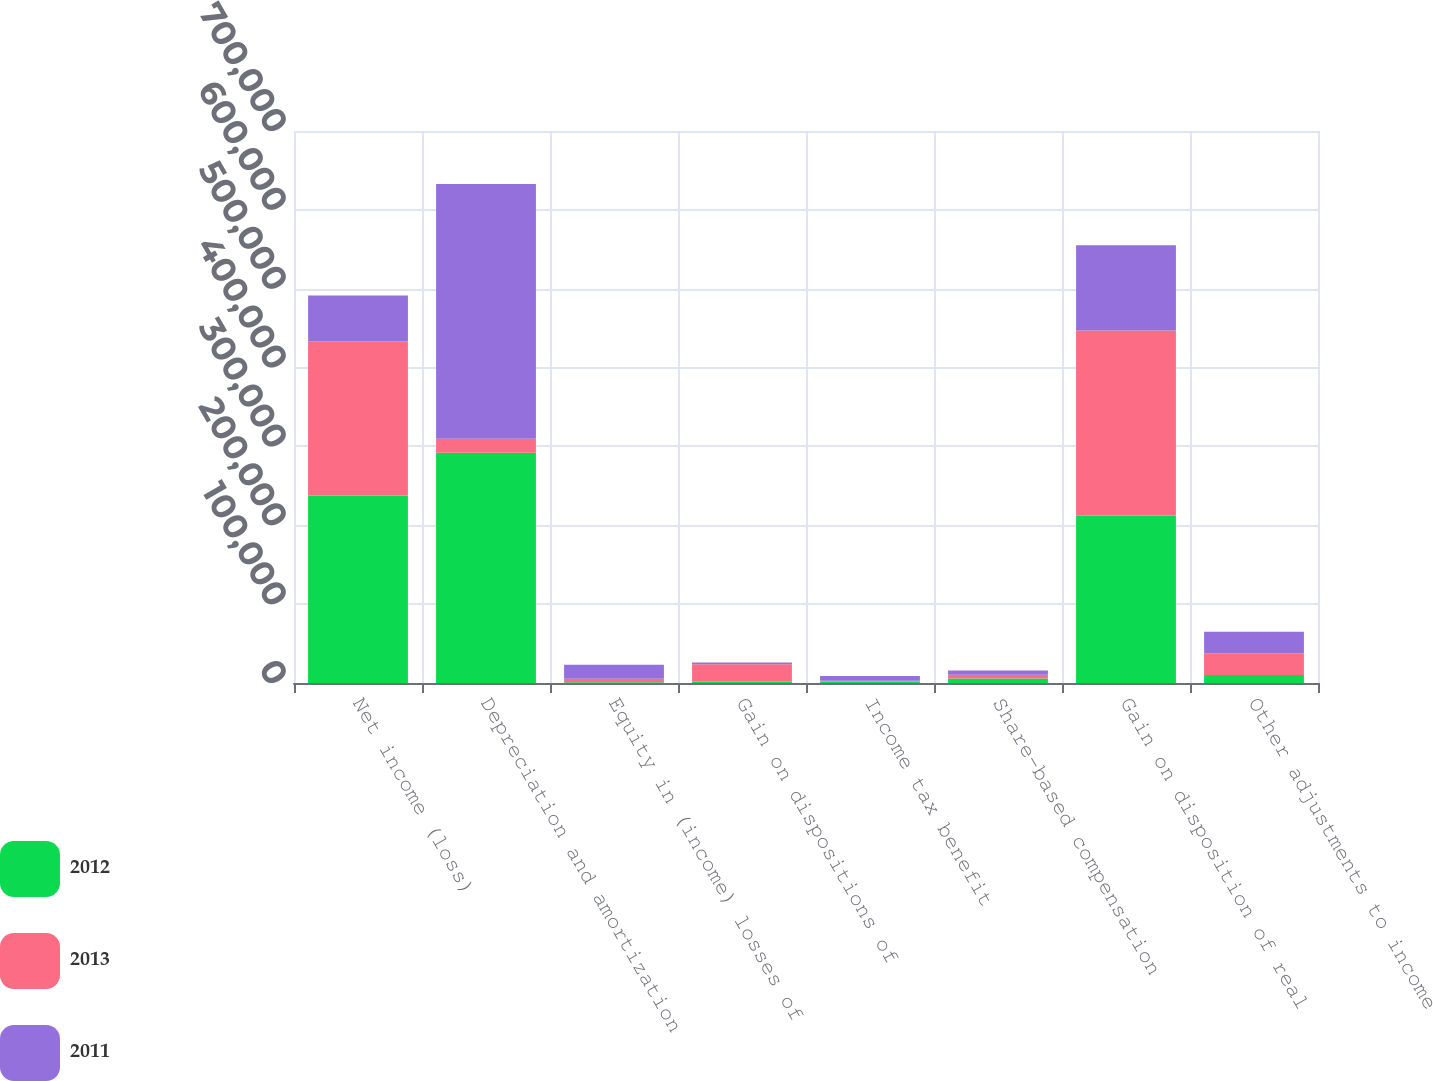<chart> <loc_0><loc_0><loc_500><loc_500><stacked_bar_chart><ecel><fcel>Net income (loss)<fcel>Depreciation and amortization<fcel>Equity in (income) losses of<fcel>Gain on dispositions of<fcel>Income tax benefit<fcel>Share-based compensation<fcel>Gain on disposition of real<fcel>Other adjustments to income<nl><fcel>2012<fcel>237825<fcel>291910<fcel>926<fcel>1797<fcel>1959<fcel>5645<fcel>212459<fcel>10019<nl><fcel>2013<fcel>195361<fcel>17721<fcel>4408<fcel>21886<fcel>858<fcel>4871<fcel>234530<fcel>27854<nl><fcel>2011<fcel>58164<fcel>323233<fcel>17721<fcel>2403<fcel>5941<fcel>5381<fcel>108203<fcel>27088<nl></chart> 